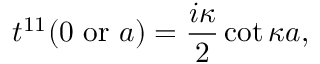Convert formula to latex. <formula><loc_0><loc_0><loc_500><loc_500>t ^ { 1 1 } ( 0 o r a ) = { \frac { i \kappa } { 2 } } \cot \kappa a ,</formula> 